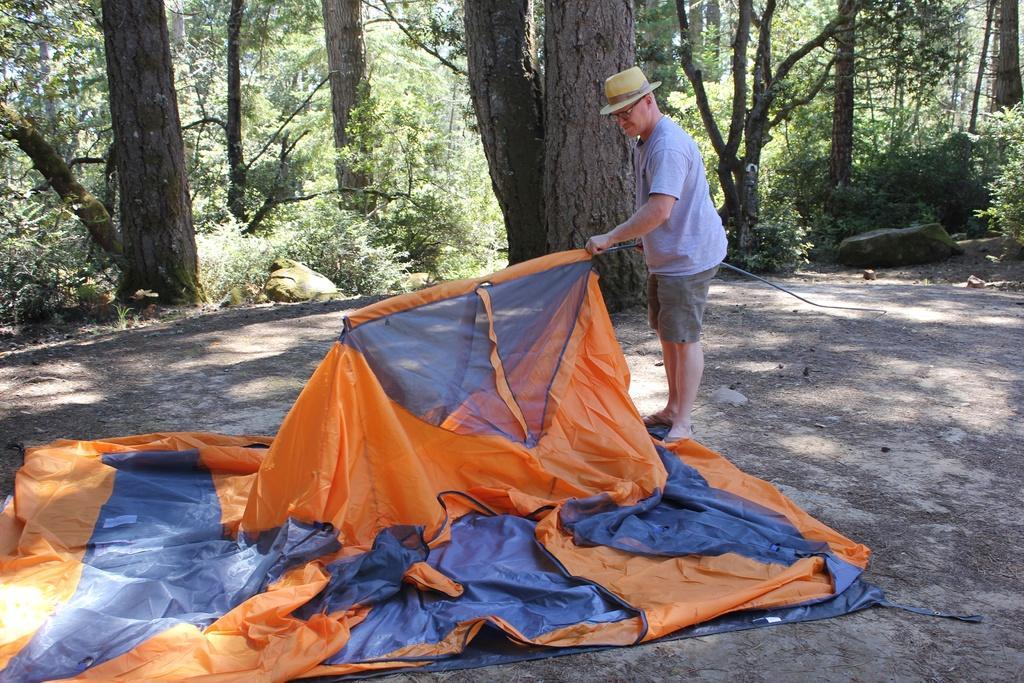Describe this image in one or two sentences. In this picture there is a man standing and wore hat and spectacle and holding an object. We can see cloth. In the background of the image we can see trees and rocks. 